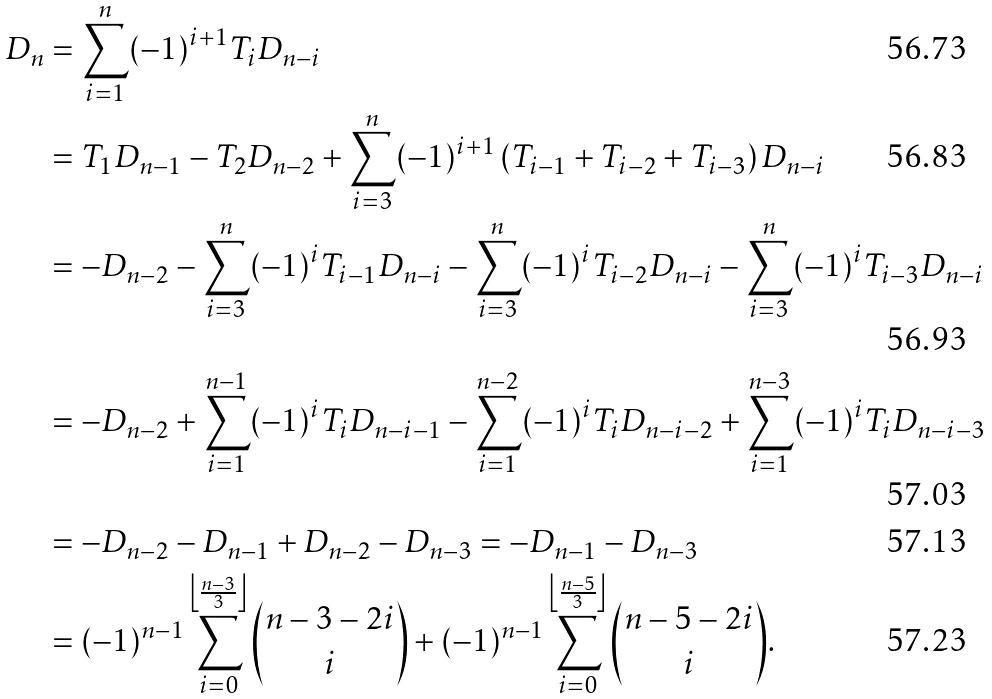Convert formula to latex. <formula><loc_0><loc_0><loc_500><loc_500>D _ { n } & = \sum _ { i = 1 } ^ { n } ( - 1 ) ^ { i + 1 } T _ { i } D _ { n - i } \\ & = T _ { 1 } D _ { n - 1 } - T _ { 2 } D _ { n - 2 } + \sum _ { i = 3 } ^ { n } ( - 1 ) ^ { i + 1 } \left ( T _ { i - 1 } + T _ { i - 2 } + T _ { i - 3 } \right ) D _ { n - i } \\ & = - D _ { n - 2 } - \sum _ { i = 3 } ^ { n } ( - 1 ) ^ { i } T _ { i - 1 } D _ { n - i } - \sum _ { i = 3 } ^ { n } ( - 1 ) ^ { i } T _ { i - 2 } D _ { n - i } - \sum _ { i = 3 } ^ { n } ( - 1 ) ^ { i } T _ { i - 3 } D _ { n - i } \\ & = - D _ { n - 2 } + \sum _ { i = 1 } ^ { n - 1 } ( - 1 ) ^ { i } T _ { i } D _ { n - i - 1 } - \sum _ { i = 1 } ^ { n - 2 } ( - 1 ) ^ { i } T _ { i } D _ { n - i - 2 } + \sum _ { i = 1 } ^ { n - 3 } ( - 1 ) ^ { i } T _ { i } D _ { n - i - 3 } \\ & = - D _ { n - 2 } - D _ { n - 1 } + D _ { n - 2 } - D _ { n - 3 } = - D _ { n - 1 } - D _ { n - 3 } \\ & = ( - 1 ) ^ { n - 1 } \sum _ { i = 0 } ^ { \left \lfloor \frac { n - 3 } { 3 } \right \rfloor } { n - 3 - 2 i \choose i } + ( - 1 ) ^ { n - 1 } \sum _ { i = 0 } ^ { \left \lfloor \frac { n - 5 } { 3 } \right \rfloor } { n - 5 - 2 i \choose i } .</formula> 